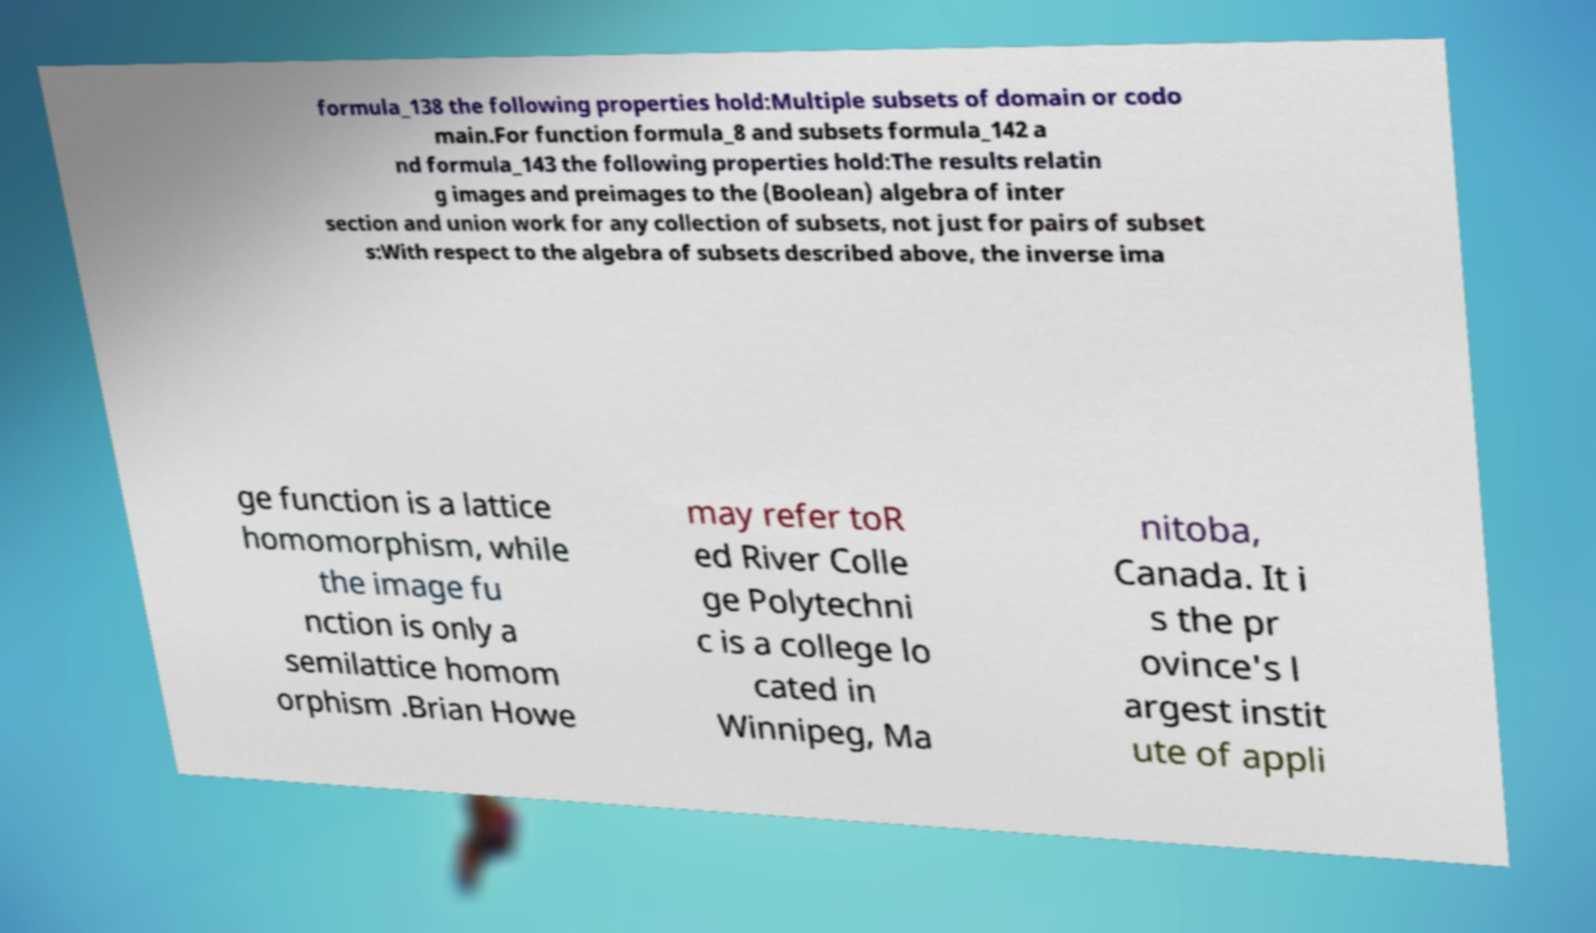What messages or text are displayed in this image? I need them in a readable, typed format. formula_138 the following properties hold:Multiple subsets of domain or codo main.For function formula_8 and subsets formula_142 a nd formula_143 the following properties hold:The results relatin g images and preimages to the (Boolean) algebra of inter section and union work for any collection of subsets, not just for pairs of subset s:With respect to the algebra of subsets described above, the inverse ima ge function is a lattice homomorphism, while the image fu nction is only a semilattice homom orphism .Brian Howe may refer toR ed River Colle ge Polytechni c is a college lo cated in Winnipeg, Ma nitoba, Canada. It i s the pr ovince's l argest instit ute of appli 